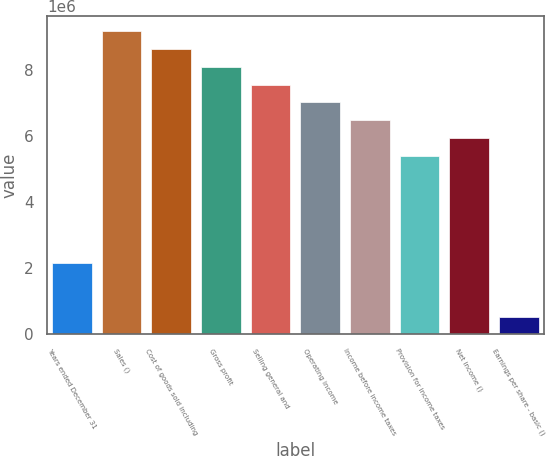Convert chart to OTSL. <chart><loc_0><loc_0><loc_500><loc_500><bar_chart><fcel>Years ended December 31<fcel>Sales ()<fcel>Cost of goods sold including<fcel>Gross profit<fcel>Selling general and<fcel>Operating income<fcel>Income before income taxes<fcel>Provision for income taxes<fcel>Net income ()<fcel>Earnings per share - basic ()<nl><fcel>2.15901e+06<fcel>9.17579e+06<fcel>8.63604e+06<fcel>8.09629e+06<fcel>7.55653e+06<fcel>7.01678e+06<fcel>6.47703e+06<fcel>5.39752e+06<fcel>5.93728e+06<fcel>539755<nl></chart> 